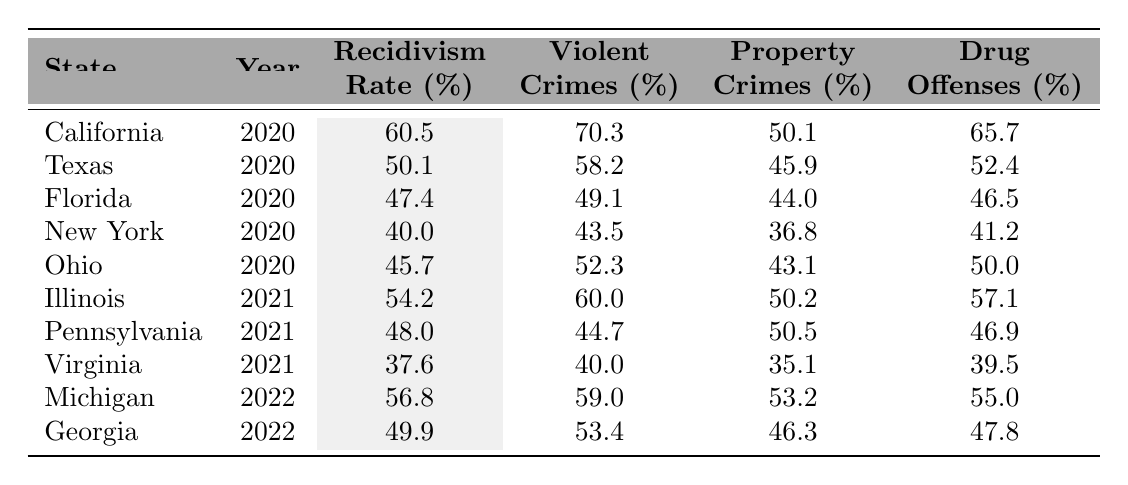What is the recidivism rate in California for the year 2020? The table indicates that California has a recorded recidivism rate of 60.5% for the year 2020.
Answer: 60.5% Which state had the lowest recidivism rate in 2021? In 2021, Virginia had the lowest recidivism rate of 37.6%, when compared to Illinois and Pennsylvania.
Answer: Virginia What is the difference in recidivism rates between Texas and Florida in 2020? Texas has a recidivism rate of 50.1% and Florida has 47.4%, so the difference is 50.1% - 47.4% = 2.7%.
Answer: 2.7% What percentage of violent crimes does New York have in 2020? According to the table, New York's percentage of violent crimes in 2020 is 43.5%.
Answer: 43.5% Which state, between Michigan and California, had a higher drug offense percentage in their respective years? Michigan has a drug offense percentage of 55.0% in 2022, while California in 2020 had 65.7%. Therefore, California had a higher percentage.
Answer: California What is the average recidivism rate for the states listed in the year 2020? The recidivism rates for 2020 are 60.5%, 50.1%, 47.4%, 40.0%, and 45.7%. The sum is 60.5 + 50.1 + 47.4 + 40.0 + 45.7 = 243.7, and there are 5 states, so the average is 243.7 / 5 = 48.74%.
Answer: 48.74% Is the recidivism rate in Illinois higher than the rate in Virginia for 2021? In 2021, Illinois has a recidivism rate of 54.2%, and Virginia has 37.6%, thus Illinois has a higher rate.
Answer: Yes Which state has the highest percentage of property crimes in 2022 and what is that percentage? In 2022, Michigan has the highest percentage of property crimes at 53.2%.
Answer: 53.2% How does the recidivism rate of Texas compare to that of New York in 2020? Texas has a recidivism rate of 50.1% while New York has 40.0%, making Texas higher by 10.1%.
Answer: Texas is higher by 10.1% Which year recorded the highest average recidivism rate among all states in the table? California in 2020 had 60.5%, Texas had 50.1%, Florida had 47.4%, New York had 40.0%, and Ohio had 45.7%. The average for 2020 is 48.74%.  In 2021, Illinois had 54.2%, Pennsylvania 48.0%, and Virginia 37.6%, averaging 46.6%. In 2022, Michigan had 56.8% and Georgia 49.9%, averaging 53.4%. Therefore, 2020 had the highest average at 48.74%.
Answer: 2020 What is the trend in recidivism rates from 2020 to 2022 when comparing California and Georgia? California's rate decreased from 60.5% in 2020 to 49.9% in 2022 (only for Georgia), while Georgia's rate in 2022 is 49.9%. California experienced a decrease overall.
Answer: Decrease 